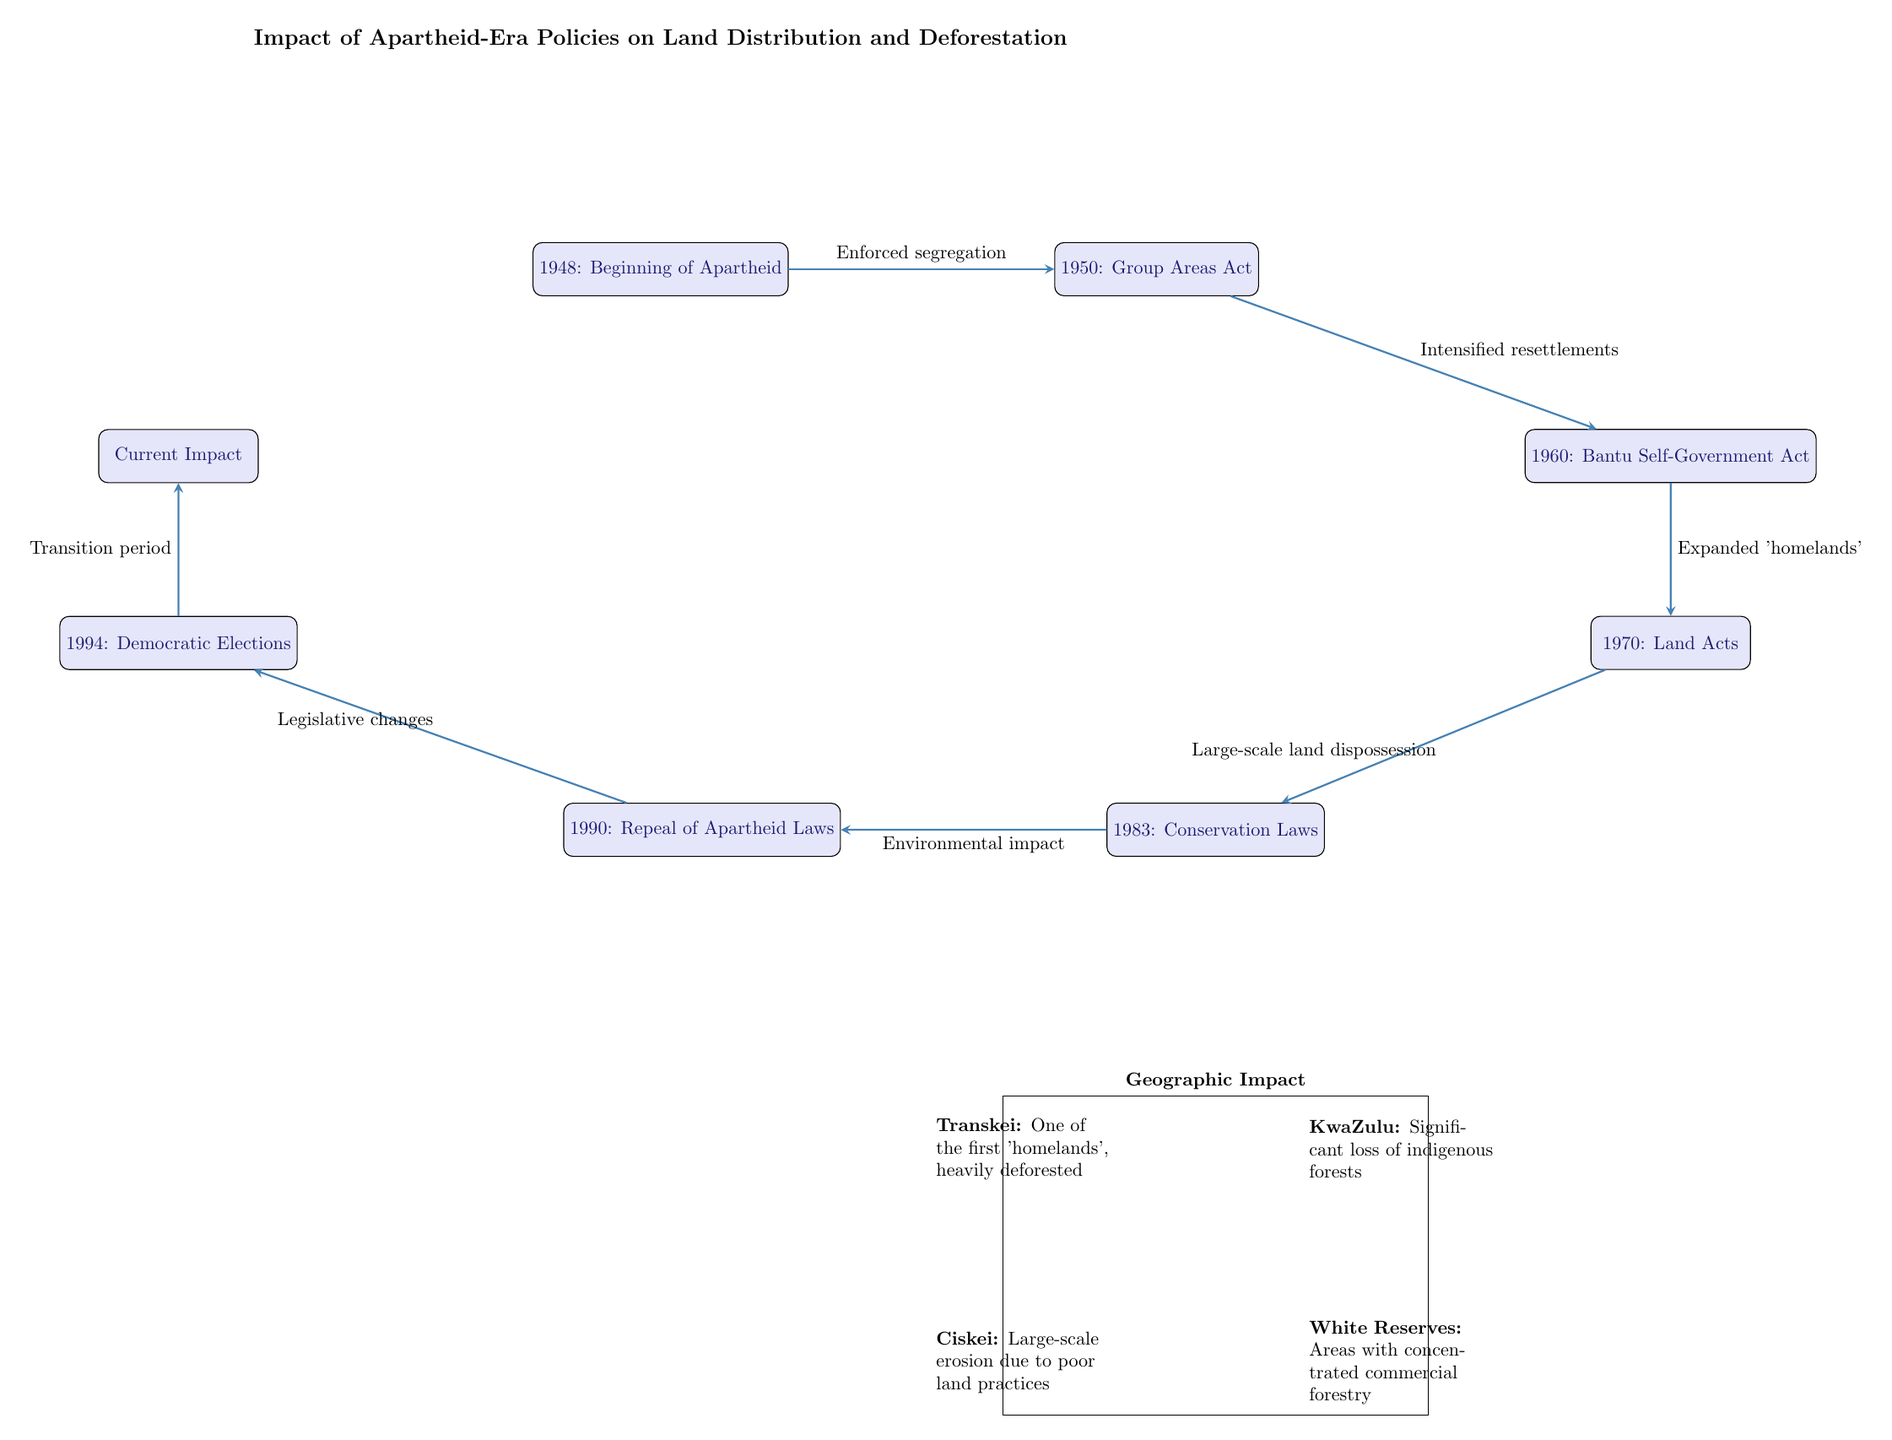What event marks the beginning of Apartheid? The node labeled '1948: Beginning of Apartheid' indicates the start of this policy.
Answer: 1948 What legislation was introduced in 1950? The node connected to 1948, labeled '1950: Group Areas Act', shows the legislation that was enacted in that year.
Answer: Group Areas Act What happened in 1960? According to the diagram, the event labeled '1960: Bantu Self-Government Act' occurred in that year.
Answer: Bantu Self-Government Act How did the Land Acts of 1970 contribute to land dispossession? The path from '1970: Land Acts' to '1983: Conservation Laws' is labeled 'Large-scale land dispossession', indicating that the Land Acts facilitated this dispossession.
Answer: Large-scale land dispossession What was the outcome of the repeal of apartheid laws in 1990? The arrow connects '1990: Repeal of Apartheid Laws' to '1994: Democratic Elections', showing that the repeal led to democratic changes.
Answer: Legislative changes How does the current impact relate to events from 1994? The diagram shows an arrow from '1994: Democratic Elections' to 'Current Impact', indicating that the current situation is influenced by the changes from 1994.
Answer: Transition period Which geographic area was described as one of the first 'homelands'? The diagram indicates 'Transkei' as one of the first 'homelands', which is marked in the geographic section.
Answer: Transkei How did conservation laws affect natural resources? The arrow labeled 'Environmental impact' connecting '1983: Conservation Laws' to '1990: Repeal of Apartheid Laws' suggests that these laws had an environmental effect on natural resources.
Answer: Environmental impact What is indicated about KwaZulu in the geographic section? The note near KwaZulu states it experienced a significant loss of indigenous forests, providing information about the environmental consequences in that area.
Answer: Significant loss of indigenous forests 